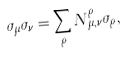Convert formula to latex. <formula><loc_0><loc_0><loc_500><loc_500>\sigma _ { \mu } \sigma _ { \nu } = \sum _ { \rho } N _ { \mu , \nu } ^ { \rho } \sigma _ { \rho } ,</formula> 